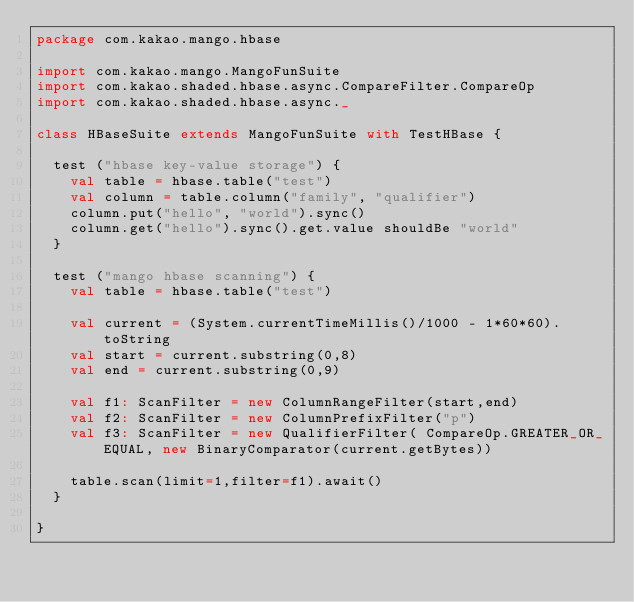Convert code to text. <code><loc_0><loc_0><loc_500><loc_500><_Scala_>package com.kakao.mango.hbase

import com.kakao.mango.MangoFunSuite
import com.kakao.shaded.hbase.async.CompareFilter.CompareOp
import com.kakao.shaded.hbase.async._

class HBaseSuite extends MangoFunSuite with TestHBase {

  test ("hbase key-value storage") {
    val table = hbase.table("test")
    val column = table.column("family", "qualifier")
    column.put("hello", "world").sync()
    column.get("hello").sync().get.value shouldBe "world"
  }

  test ("mango hbase scanning") {
    val table = hbase.table("test")

    val current = (System.currentTimeMillis()/1000 - 1*60*60).toString
    val start = current.substring(0,8)
    val end = current.substring(0,9)

    val f1: ScanFilter = new ColumnRangeFilter(start,end)
    val f2: ScanFilter = new ColumnPrefixFilter("p")
    val f3: ScanFilter = new QualifierFilter( CompareOp.GREATER_OR_EQUAL, new BinaryComparator(current.getBytes))

    table.scan(limit=1,filter=f1).await()
  }

}
</code> 